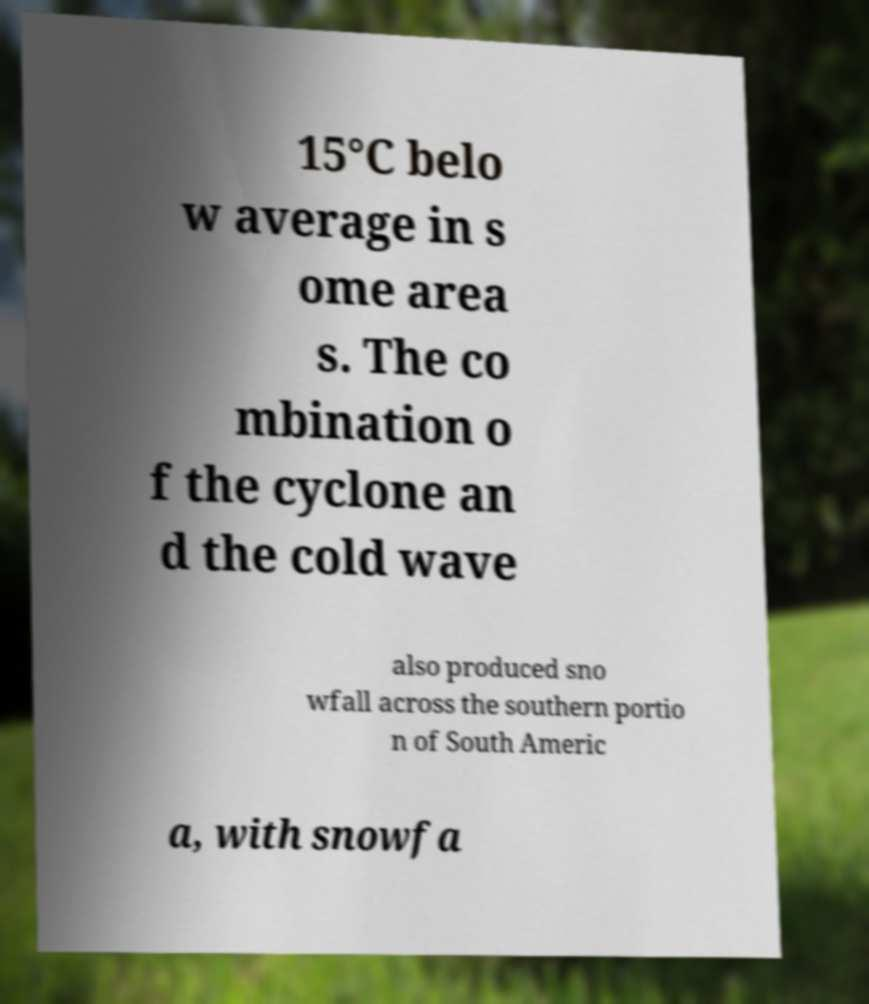Please read and relay the text visible in this image. What does it say? 15°C belo w average in s ome area s. The co mbination o f the cyclone an d the cold wave also produced sno wfall across the southern portio n of South Americ a, with snowfa 